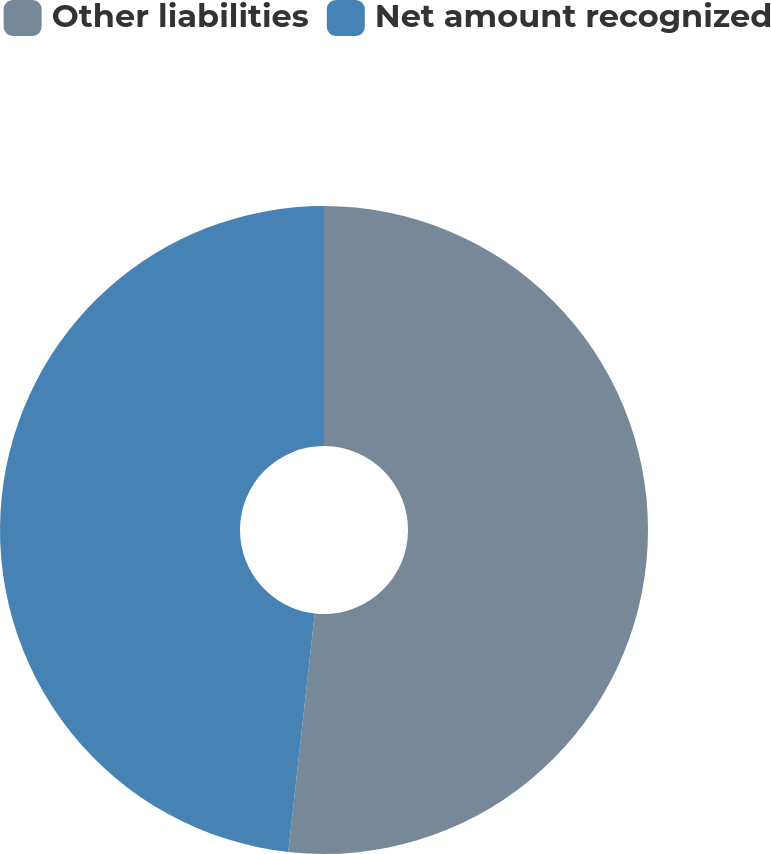Convert chart. <chart><loc_0><loc_0><loc_500><loc_500><pie_chart><fcel>Other liabilities<fcel>Net amount recognized<nl><fcel>51.76%<fcel>48.24%<nl></chart> 